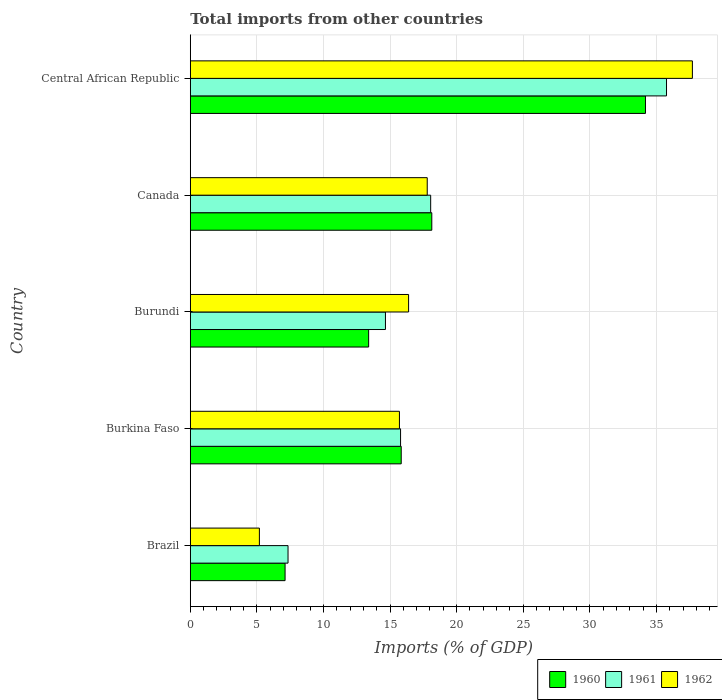How many different coloured bars are there?
Offer a terse response. 3. Are the number of bars on each tick of the Y-axis equal?
Your answer should be compact. Yes. How many bars are there on the 3rd tick from the top?
Keep it short and to the point. 3. What is the label of the 3rd group of bars from the top?
Offer a terse response. Burundi. In how many cases, is the number of bars for a given country not equal to the number of legend labels?
Offer a terse response. 0. What is the total imports in 1962 in Burkina Faso?
Your response must be concise. 15.71. Across all countries, what is the maximum total imports in 1962?
Your answer should be very brief. 37.7. Across all countries, what is the minimum total imports in 1960?
Make the answer very short. 7.12. In which country was the total imports in 1961 maximum?
Your response must be concise. Central African Republic. In which country was the total imports in 1961 minimum?
Offer a very short reply. Brazil. What is the total total imports in 1962 in the graph?
Make the answer very short. 92.79. What is the difference between the total imports in 1962 in Brazil and that in Burundi?
Keep it short and to the point. -11.2. What is the difference between the total imports in 1962 in Burkina Faso and the total imports in 1960 in Burundi?
Provide a succinct answer. 2.31. What is the average total imports in 1960 per country?
Ensure brevity in your answer.  17.73. What is the difference between the total imports in 1961 and total imports in 1962 in Burundi?
Offer a very short reply. -1.74. In how many countries, is the total imports in 1960 greater than 7 %?
Your answer should be very brief. 5. What is the ratio of the total imports in 1962 in Brazil to that in Burkina Faso?
Your response must be concise. 0.33. Is the total imports in 1960 in Brazil less than that in Burkina Faso?
Provide a succinct answer. Yes. Is the difference between the total imports in 1961 in Burkina Faso and Burundi greater than the difference between the total imports in 1962 in Burkina Faso and Burundi?
Provide a succinct answer. Yes. What is the difference between the highest and the second highest total imports in 1961?
Your answer should be compact. 17.71. What is the difference between the highest and the lowest total imports in 1961?
Make the answer very short. 28.42. In how many countries, is the total imports in 1961 greater than the average total imports in 1961 taken over all countries?
Provide a short and direct response. 1. What does the 1st bar from the top in Brazil represents?
Your response must be concise. 1962. What does the 2nd bar from the bottom in Canada represents?
Keep it short and to the point. 1961. How many countries are there in the graph?
Offer a very short reply. 5. What is the difference between two consecutive major ticks on the X-axis?
Keep it short and to the point. 5. Are the values on the major ticks of X-axis written in scientific E-notation?
Your answer should be compact. No. How many legend labels are there?
Make the answer very short. 3. What is the title of the graph?
Your answer should be very brief. Total imports from other countries. Does "2008" appear as one of the legend labels in the graph?
Keep it short and to the point. No. What is the label or title of the X-axis?
Make the answer very short. Imports (% of GDP). What is the label or title of the Y-axis?
Offer a terse response. Country. What is the Imports (% of GDP) of 1960 in Brazil?
Keep it short and to the point. 7.12. What is the Imports (% of GDP) of 1961 in Brazil?
Keep it short and to the point. 7.34. What is the Imports (% of GDP) in 1962 in Brazil?
Your answer should be very brief. 5.19. What is the Imports (% of GDP) of 1960 in Burkina Faso?
Make the answer very short. 15.84. What is the Imports (% of GDP) in 1961 in Burkina Faso?
Provide a short and direct response. 15.79. What is the Imports (% of GDP) of 1962 in Burkina Faso?
Keep it short and to the point. 15.71. What is the Imports (% of GDP) in 1960 in Burundi?
Offer a very short reply. 13.39. What is the Imports (% of GDP) of 1961 in Burundi?
Keep it short and to the point. 14.66. What is the Imports (% of GDP) in 1962 in Burundi?
Ensure brevity in your answer.  16.39. What is the Imports (% of GDP) of 1960 in Canada?
Provide a short and direct response. 18.14. What is the Imports (% of GDP) in 1961 in Canada?
Make the answer very short. 18.05. What is the Imports (% of GDP) of 1962 in Canada?
Offer a very short reply. 17.79. What is the Imports (% of GDP) of 1960 in Central African Republic?
Provide a short and direct response. 34.18. What is the Imports (% of GDP) in 1961 in Central African Republic?
Give a very brief answer. 35.76. What is the Imports (% of GDP) in 1962 in Central African Republic?
Offer a very short reply. 37.7. Across all countries, what is the maximum Imports (% of GDP) of 1960?
Provide a succinct answer. 34.18. Across all countries, what is the maximum Imports (% of GDP) in 1961?
Give a very brief answer. 35.76. Across all countries, what is the maximum Imports (% of GDP) in 1962?
Offer a very short reply. 37.7. Across all countries, what is the minimum Imports (% of GDP) in 1960?
Provide a short and direct response. 7.12. Across all countries, what is the minimum Imports (% of GDP) in 1961?
Ensure brevity in your answer.  7.34. Across all countries, what is the minimum Imports (% of GDP) in 1962?
Your answer should be compact. 5.19. What is the total Imports (% of GDP) in 1960 in the graph?
Keep it short and to the point. 88.67. What is the total Imports (% of GDP) of 1961 in the graph?
Offer a terse response. 91.6. What is the total Imports (% of GDP) in 1962 in the graph?
Ensure brevity in your answer.  92.79. What is the difference between the Imports (% of GDP) of 1960 in Brazil and that in Burkina Faso?
Offer a terse response. -8.72. What is the difference between the Imports (% of GDP) in 1961 in Brazil and that in Burkina Faso?
Provide a short and direct response. -8.45. What is the difference between the Imports (% of GDP) of 1962 in Brazil and that in Burkina Faso?
Provide a succinct answer. -10.52. What is the difference between the Imports (% of GDP) of 1960 in Brazil and that in Burundi?
Make the answer very short. -6.28. What is the difference between the Imports (% of GDP) of 1961 in Brazil and that in Burundi?
Provide a succinct answer. -7.32. What is the difference between the Imports (% of GDP) of 1962 in Brazil and that in Burundi?
Provide a succinct answer. -11.2. What is the difference between the Imports (% of GDP) in 1960 in Brazil and that in Canada?
Ensure brevity in your answer.  -11.02. What is the difference between the Imports (% of GDP) in 1961 in Brazil and that in Canada?
Ensure brevity in your answer.  -10.71. What is the difference between the Imports (% of GDP) in 1962 in Brazil and that in Canada?
Give a very brief answer. -12.6. What is the difference between the Imports (% of GDP) of 1960 in Brazil and that in Central African Republic?
Make the answer very short. -27.06. What is the difference between the Imports (% of GDP) of 1961 in Brazil and that in Central African Republic?
Your answer should be compact. -28.42. What is the difference between the Imports (% of GDP) in 1962 in Brazil and that in Central African Republic?
Your answer should be very brief. -32.52. What is the difference between the Imports (% of GDP) of 1960 in Burkina Faso and that in Burundi?
Provide a short and direct response. 2.45. What is the difference between the Imports (% of GDP) of 1961 in Burkina Faso and that in Burundi?
Offer a very short reply. 1.13. What is the difference between the Imports (% of GDP) in 1962 in Burkina Faso and that in Burundi?
Your answer should be compact. -0.69. What is the difference between the Imports (% of GDP) in 1960 in Burkina Faso and that in Canada?
Your response must be concise. -2.3. What is the difference between the Imports (% of GDP) in 1961 in Burkina Faso and that in Canada?
Make the answer very short. -2.26. What is the difference between the Imports (% of GDP) of 1962 in Burkina Faso and that in Canada?
Provide a short and direct response. -2.09. What is the difference between the Imports (% of GDP) of 1960 in Burkina Faso and that in Central African Republic?
Offer a terse response. -18.34. What is the difference between the Imports (% of GDP) of 1961 in Burkina Faso and that in Central African Republic?
Provide a succinct answer. -19.97. What is the difference between the Imports (% of GDP) in 1962 in Burkina Faso and that in Central African Republic?
Provide a succinct answer. -22. What is the difference between the Imports (% of GDP) in 1960 in Burundi and that in Canada?
Provide a short and direct response. -4.74. What is the difference between the Imports (% of GDP) in 1961 in Burundi and that in Canada?
Your answer should be very brief. -3.4. What is the difference between the Imports (% of GDP) of 1962 in Burundi and that in Canada?
Provide a short and direct response. -1.4. What is the difference between the Imports (% of GDP) of 1960 in Burundi and that in Central African Republic?
Your answer should be compact. -20.79. What is the difference between the Imports (% of GDP) of 1961 in Burundi and that in Central African Republic?
Ensure brevity in your answer.  -21.11. What is the difference between the Imports (% of GDP) in 1962 in Burundi and that in Central African Republic?
Your response must be concise. -21.31. What is the difference between the Imports (% of GDP) in 1960 in Canada and that in Central African Republic?
Give a very brief answer. -16.05. What is the difference between the Imports (% of GDP) of 1961 in Canada and that in Central African Republic?
Provide a short and direct response. -17.71. What is the difference between the Imports (% of GDP) in 1962 in Canada and that in Central African Republic?
Your answer should be very brief. -19.91. What is the difference between the Imports (% of GDP) of 1960 in Brazil and the Imports (% of GDP) of 1961 in Burkina Faso?
Your answer should be compact. -8.67. What is the difference between the Imports (% of GDP) of 1960 in Brazil and the Imports (% of GDP) of 1962 in Burkina Faso?
Give a very brief answer. -8.59. What is the difference between the Imports (% of GDP) of 1961 in Brazil and the Imports (% of GDP) of 1962 in Burkina Faso?
Provide a short and direct response. -8.37. What is the difference between the Imports (% of GDP) of 1960 in Brazil and the Imports (% of GDP) of 1961 in Burundi?
Keep it short and to the point. -7.54. What is the difference between the Imports (% of GDP) in 1960 in Brazil and the Imports (% of GDP) in 1962 in Burundi?
Provide a succinct answer. -9.28. What is the difference between the Imports (% of GDP) of 1961 in Brazil and the Imports (% of GDP) of 1962 in Burundi?
Your response must be concise. -9.05. What is the difference between the Imports (% of GDP) in 1960 in Brazil and the Imports (% of GDP) in 1961 in Canada?
Your answer should be compact. -10.93. What is the difference between the Imports (% of GDP) in 1960 in Brazil and the Imports (% of GDP) in 1962 in Canada?
Your answer should be compact. -10.68. What is the difference between the Imports (% of GDP) in 1961 in Brazil and the Imports (% of GDP) in 1962 in Canada?
Provide a succinct answer. -10.45. What is the difference between the Imports (% of GDP) in 1960 in Brazil and the Imports (% of GDP) in 1961 in Central African Republic?
Ensure brevity in your answer.  -28.64. What is the difference between the Imports (% of GDP) of 1960 in Brazil and the Imports (% of GDP) of 1962 in Central African Republic?
Your answer should be compact. -30.59. What is the difference between the Imports (% of GDP) in 1961 in Brazil and the Imports (% of GDP) in 1962 in Central African Republic?
Offer a terse response. -30.37. What is the difference between the Imports (% of GDP) of 1960 in Burkina Faso and the Imports (% of GDP) of 1961 in Burundi?
Provide a succinct answer. 1.18. What is the difference between the Imports (% of GDP) in 1960 in Burkina Faso and the Imports (% of GDP) in 1962 in Burundi?
Offer a very short reply. -0.55. What is the difference between the Imports (% of GDP) of 1961 in Burkina Faso and the Imports (% of GDP) of 1962 in Burundi?
Make the answer very short. -0.6. What is the difference between the Imports (% of GDP) in 1960 in Burkina Faso and the Imports (% of GDP) in 1961 in Canada?
Make the answer very short. -2.21. What is the difference between the Imports (% of GDP) of 1960 in Burkina Faso and the Imports (% of GDP) of 1962 in Canada?
Your answer should be compact. -1.95. What is the difference between the Imports (% of GDP) in 1961 in Burkina Faso and the Imports (% of GDP) in 1962 in Canada?
Provide a short and direct response. -2. What is the difference between the Imports (% of GDP) of 1960 in Burkina Faso and the Imports (% of GDP) of 1961 in Central African Republic?
Make the answer very short. -19.92. What is the difference between the Imports (% of GDP) in 1960 in Burkina Faso and the Imports (% of GDP) in 1962 in Central African Republic?
Your answer should be very brief. -21.87. What is the difference between the Imports (% of GDP) of 1961 in Burkina Faso and the Imports (% of GDP) of 1962 in Central African Republic?
Ensure brevity in your answer.  -21.91. What is the difference between the Imports (% of GDP) of 1960 in Burundi and the Imports (% of GDP) of 1961 in Canada?
Offer a very short reply. -4.66. What is the difference between the Imports (% of GDP) in 1960 in Burundi and the Imports (% of GDP) in 1962 in Canada?
Make the answer very short. -4.4. What is the difference between the Imports (% of GDP) of 1961 in Burundi and the Imports (% of GDP) of 1962 in Canada?
Provide a succinct answer. -3.14. What is the difference between the Imports (% of GDP) of 1960 in Burundi and the Imports (% of GDP) of 1961 in Central African Republic?
Offer a very short reply. -22.37. What is the difference between the Imports (% of GDP) of 1960 in Burundi and the Imports (% of GDP) of 1962 in Central African Republic?
Keep it short and to the point. -24.31. What is the difference between the Imports (% of GDP) in 1961 in Burundi and the Imports (% of GDP) in 1962 in Central African Republic?
Your answer should be very brief. -23.05. What is the difference between the Imports (% of GDP) in 1960 in Canada and the Imports (% of GDP) in 1961 in Central African Republic?
Provide a short and direct response. -17.63. What is the difference between the Imports (% of GDP) in 1960 in Canada and the Imports (% of GDP) in 1962 in Central African Republic?
Provide a short and direct response. -19.57. What is the difference between the Imports (% of GDP) in 1961 in Canada and the Imports (% of GDP) in 1962 in Central African Republic?
Offer a very short reply. -19.65. What is the average Imports (% of GDP) of 1960 per country?
Offer a very short reply. 17.73. What is the average Imports (% of GDP) in 1961 per country?
Make the answer very short. 18.32. What is the average Imports (% of GDP) of 1962 per country?
Make the answer very short. 18.56. What is the difference between the Imports (% of GDP) of 1960 and Imports (% of GDP) of 1961 in Brazil?
Your response must be concise. -0.22. What is the difference between the Imports (% of GDP) in 1960 and Imports (% of GDP) in 1962 in Brazil?
Make the answer very short. 1.93. What is the difference between the Imports (% of GDP) of 1961 and Imports (% of GDP) of 1962 in Brazil?
Provide a short and direct response. 2.15. What is the difference between the Imports (% of GDP) in 1960 and Imports (% of GDP) in 1961 in Burkina Faso?
Offer a very short reply. 0.05. What is the difference between the Imports (% of GDP) in 1960 and Imports (% of GDP) in 1962 in Burkina Faso?
Your answer should be very brief. 0.13. What is the difference between the Imports (% of GDP) of 1961 and Imports (% of GDP) of 1962 in Burkina Faso?
Offer a terse response. 0.08. What is the difference between the Imports (% of GDP) in 1960 and Imports (% of GDP) in 1961 in Burundi?
Offer a terse response. -1.26. What is the difference between the Imports (% of GDP) in 1960 and Imports (% of GDP) in 1962 in Burundi?
Provide a short and direct response. -3. What is the difference between the Imports (% of GDP) in 1961 and Imports (% of GDP) in 1962 in Burundi?
Provide a succinct answer. -1.74. What is the difference between the Imports (% of GDP) of 1960 and Imports (% of GDP) of 1961 in Canada?
Offer a terse response. 0.08. What is the difference between the Imports (% of GDP) in 1960 and Imports (% of GDP) in 1962 in Canada?
Offer a terse response. 0.34. What is the difference between the Imports (% of GDP) in 1961 and Imports (% of GDP) in 1962 in Canada?
Offer a very short reply. 0.26. What is the difference between the Imports (% of GDP) of 1960 and Imports (% of GDP) of 1961 in Central African Republic?
Ensure brevity in your answer.  -1.58. What is the difference between the Imports (% of GDP) in 1960 and Imports (% of GDP) in 1962 in Central African Republic?
Your response must be concise. -3.52. What is the difference between the Imports (% of GDP) of 1961 and Imports (% of GDP) of 1962 in Central African Republic?
Keep it short and to the point. -1.94. What is the ratio of the Imports (% of GDP) in 1960 in Brazil to that in Burkina Faso?
Make the answer very short. 0.45. What is the ratio of the Imports (% of GDP) of 1961 in Brazil to that in Burkina Faso?
Ensure brevity in your answer.  0.46. What is the ratio of the Imports (% of GDP) in 1962 in Brazil to that in Burkina Faso?
Provide a succinct answer. 0.33. What is the ratio of the Imports (% of GDP) of 1960 in Brazil to that in Burundi?
Keep it short and to the point. 0.53. What is the ratio of the Imports (% of GDP) of 1961 in Brazil to that in Burundi?
Provide a succinct answer. 0.5. What is the ratio of the Imports (% of GDP) of 1962 in Brazil to that in Burundi?
Give a very brief answer. 0.32. What is the ratio of the Imports (% of GDP) of 1960 in Brazil to that in Canada?
Provide a short and direct response. 0.39. What is the ratio of the Imports (% of GDP) in 1961 in Brazil to that in Canada?
Offer a terse response. 0.41. What is the ratio of the Imports (% of GDP) of 1962 in Brazil to that in Canada?
Offer a terse response. 0.29. What is the ratio of the Imports (% of GDP) in 1960 in Brazil to that in Central African Republic?
Provide a succinct answer. 0.21. What is the ratio of the Imports (% of GDP) of 1961 in Brazil to that in Central African Republic?
Ensure brevity in your answer.  0.21. What is the ratio of the Imports (% of GDP) in 1962 in Brazil to that in Central African Republic?
Your answer should be very brief. 0.14. What is the ratio of the Imports (% of GDP) of 1960 in Burkina Faso to that in Burundi?
Give a very brief answer. 1.18. What is the ratio of the Imports (% of GDP) in 1961 in Burkina Faso to that in Burundi?
Your answer should be very brief. 1.08. What is the ratio of the Imports (% of GDP) in 1962 in Burkina Faso to that in Burundi?
Ensure brevity in your answer.  0.96. What is the ratio of the Imports (% of GDP) of 1960 in Burkina Faso to that in Canada?
Your response must be concise. 0.87. What is the ratio of the Imports (% of GDP) in 1961 in Burkina Faso to that in Canada?
Offer a terse response. 0.87. What is the ratio of the Imports (% of GDP) in 1962 in Burkina Faso to that in Canada?
Offer a very short reply. 0.88. What is the ratio of the Imports (% of GDP) of 1960 in Burkina Faso to that in Central African Republic?
Keep it short and to the point. 0.46. What is the ratio of the Imports (% of GDP) in 1961 in Burkina Faso to that in Central African Republic?
Give a very brief answer. 0.44. What is the ratio of the Imports (% of GDP) in 1962 in Burkina Faso to that in Central African Republic?
Offer a terse response. 0.42. What is the ratio of the Imports (% of GDP) in 1960 in Burundi to that in Canada?
Ensure brevity in your answer.  0.74. What is the ratio of the Imports (% of GDP) in 1961 in Burundi to that in Canada?
Ensure brevity in your answer.  0.81. What is the ratio of the Imports (% of GDP) of 1962 in Burundi to that in Canada?
Ensure brevity in your answer.  0.92. What is the ratio of the Imports (% of GDP) of 1960 in Burundi to that in Central African Republic?
Provide a succinct answer. 0.39. What is the ratio of the Imports (% of GDP) of 1961 in Burundi to that in Central African Republic?
Make the answer very short. 0.41. What is the ratio of the Imports (% of GDP) of 1962 in Burundi to that in Central African Republic?
Your response must be concise. 0.43. What is the ratio of the Imports (% of GDP) of 1960 in Canada to that in Central African Republic?
Your answer should be compact. 0.53. What is the ratio of the Imports (% of GDP) of 1961 in Canada to that in Central African Republic?
Offer a very short reply. 0.5. What is the ratio of the Imports (% of GDP) of 1962 in Canada to that in Central African Republic?
Your response must be concise. 0.47. What is the difference between the highest and the second highest Imports (% of GDP) in 1960?
Keep it short and to the point. 16.05. What is the difference between the highest and the second highest Imports (% of GDP) of 1961?
Provide a succinct answer. 17.71. What is the difference between the highest and the second highest Imports (% of GDP) of 1962?
Make the answer very short. 19.91. What is the difference between the highest and the lowest Imports (% of GDP) of 1960?
Your answer should be very brief. 27.06. What is the difference between the highest and the lowest Imports (% of GDP) of 1961?
Your response must be concise. 28.42. What is the difference between the highest and the lowest Imports (% of GDP) of 1962?
Your response must be concise. 32.52. 